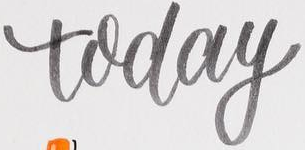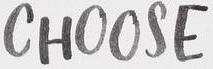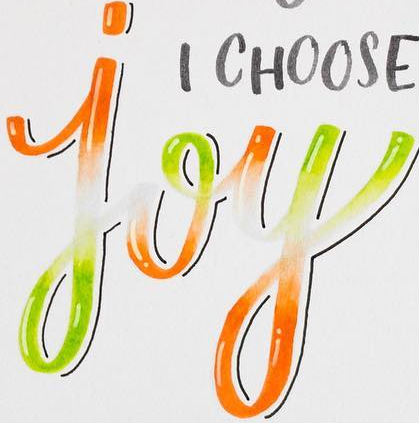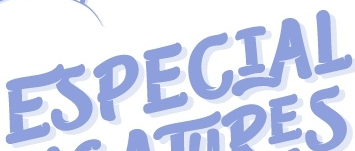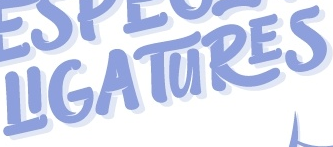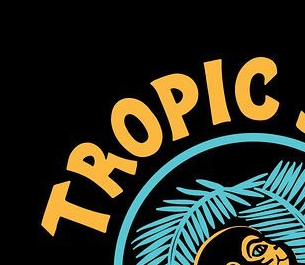What text is displayed in these images sequentially, separated by a semicolon? today; CHOOSE; joy; ESPECIAL; LIGATURES; TROPLC 